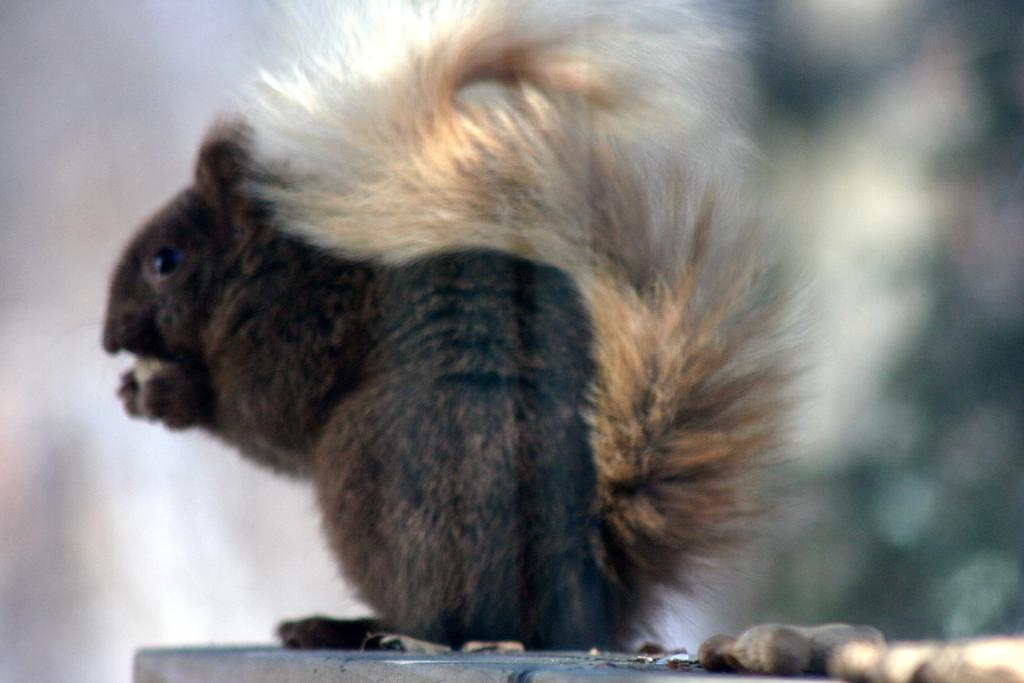What animal is present in the image? There is a squirrel in the image. Where is the squirrel located? The squirrel is on a surface. What is the squirrel holding in the image? The squirrel is holding a nut. Are there any other nuts visible in the image? Yes, there are nuts visible at the bottom right of the image. What type of business is being advertised in the image? There is no business being advertised in the image; it features a squirrel holding a nut. What caption is written below the image? There is no caption written below the image; it is a standalone photograph. 